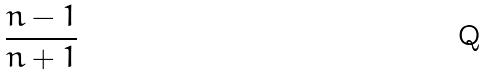Convert formula to latex. <formula><loc_0><loc_0><loc_500><loc_500>\frac { n - 1 } { n + 1 }</formula> 